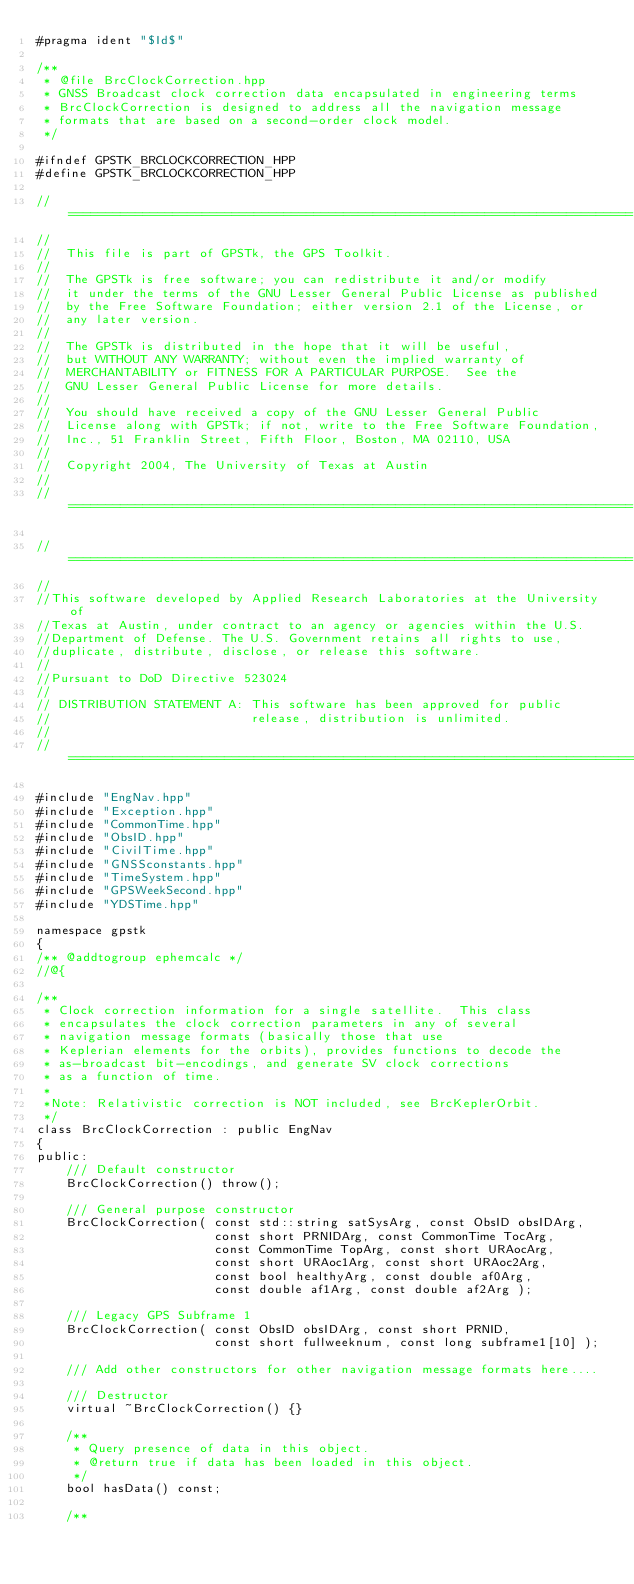<code> <loc_0><loc_0><loc_500><loc_500><_C++_>#pragma ident "$Id$"

/**
 * @file BrcClockCorrection.hpp
 * GNSS Broadcast clock correction data encapsulated in engineering terms
 * BrcClockCorrection is designed to address all the navigation message
 * formats that are based on a second-order clock model.
 */

#ifndef GPSTK_BRCLOCKCORRECTION_HPP
#define GPSTK_BRCLOCKCORRECTION_HPP

//============================================================================
//
//  This file is part of GPSTk, the GPS Toolkit.
//
//  The GPSTk is free software; you can redistribute it and/or modify
//  it under the terms of the GNU Lesser General Public License as published
//  by the Free Software Foundation; either version 2.1 of the License, or
//  any later version.
//
//  The GPSTk is distributed in the hope that it will be useful,
//  but WITHOUT ANY WARRANTY; without even the implied warranty of
//  MERCHANTABILITY or FITNESS FOR A PARTICULAR PURPOSE.  See the
//  GNU Lesser General Public License for more details.
//
//  You should have received a copy of the GNU Lesser General Public
//  License along with GPSTk; if not, write to the Free Software Foundation,
//  Inc., 51 Franklin Street, Fifth Floor, Boston, MA 02110, USA
//
//  Copyright 2004, The University of Texas at Austin
//
//============================================================================

//============================================================================
//
//This software developed by Applied Research Laboratories at the University of
//Texas at Austin, under contract to an agency or agencies within the U.S.
//Department of Defense. The U.S. Government retains all rights to use,
//duplicate, distribute, disclose, or release this software.
//
//Pursuant to DoD Directive 523024
//
// DISTRIBUTION STATEMENT A: This software has been approved for public
//                           release, distribution is unlimited.
//
//=============================================================================

#include "EngNav.hpp"
#include "Exception.hpp"
#include "CommonTime.hpp"
#include "ObsID.hpp"
#include "CivilTime.hpp"
#include "GNSSconstants.hpp"
#include "TimeSystem.hpp"
#include "GPSWeekSecond.hpp"
#include "YDSTime.hpp"

namespace gpstk
{
/** @addtogroup ephemcalc */
//@{

/**
 * Clock correction information for a single satellite.  This class
 * encapsulates the clock correction parameters in any of several
 * navigation message formats (basically those that use
 * Keplerian elements for the orbits), provides functions to decode the
 * as-broadcast bit-encodings, and generate SV clock corrections
 * as a function of time.
 *
 *Note: Relativistic correction is NOT included, see BrcKeplerOrbit.
 */
class BrcClockCorrection : public EngNav
{
public:
    /// Default constructor
    BrcClockCorrection() throw();

    /// General purpose constructor
    BrcClockCorrection( const std::string satSysArg, const ObsID obsIDArg,
                        const short PRNIDArg, const CommonTime TocArg,
                        const CommonTime TopArg, const short URAocArg,
                        const short URAoc1Arg, const short URAoc2Arg,
                        const bool healthyArg, const double af0Arg,
                        const double af1Arg, const double af2Arg );

    /// Legacy GPS Subframe 1
    BrcClockCorrection( const ObsID obsIDArg, const short PRNID,
                        const short fullweeknum, const long subframe1[10] );

    /// Add other constructors for other navigation message formats here....

    /// Destructor
    virtual ~BrcClockCorrection() {}

    /**
     * Query presence of data in this object.
     * @return true if data has been loaded in this object.
     */
    bool hasData() const;

    /**</code> 